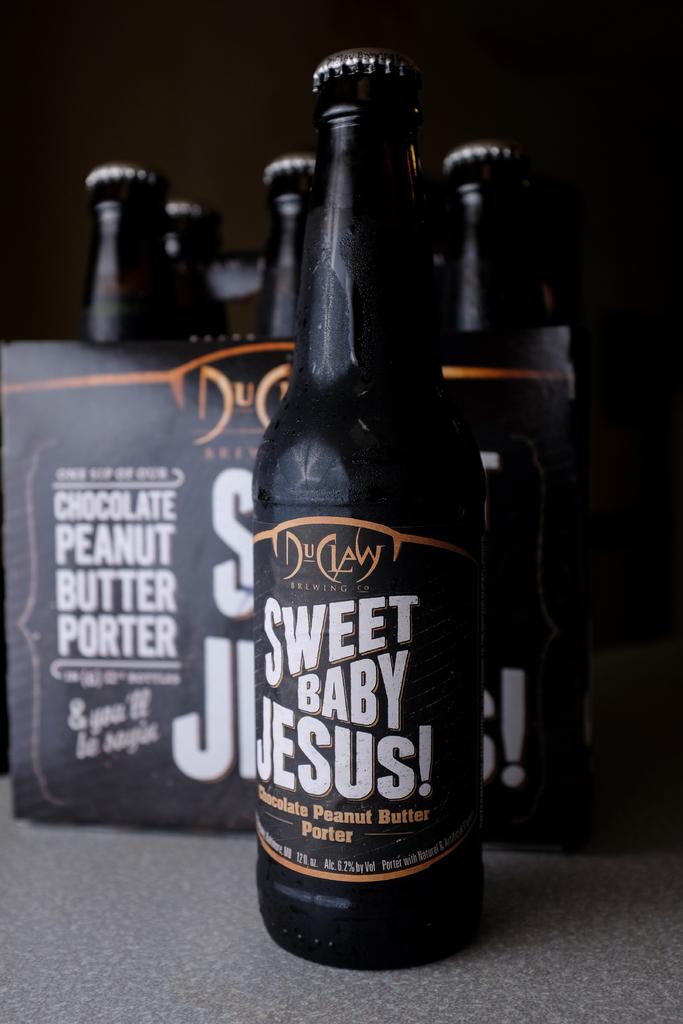What objects can be seen in the image? There are bottles and an information poster in the image. What is the color of the surface on which the bottles and poster are placed? The surface is grey. How would you describe the background of the image? The background of the image is dark. Are there any fairies visible in the image? No, there are no fairies present in the image. What type of swing can be seen in the image? There is no swing present in the image. 